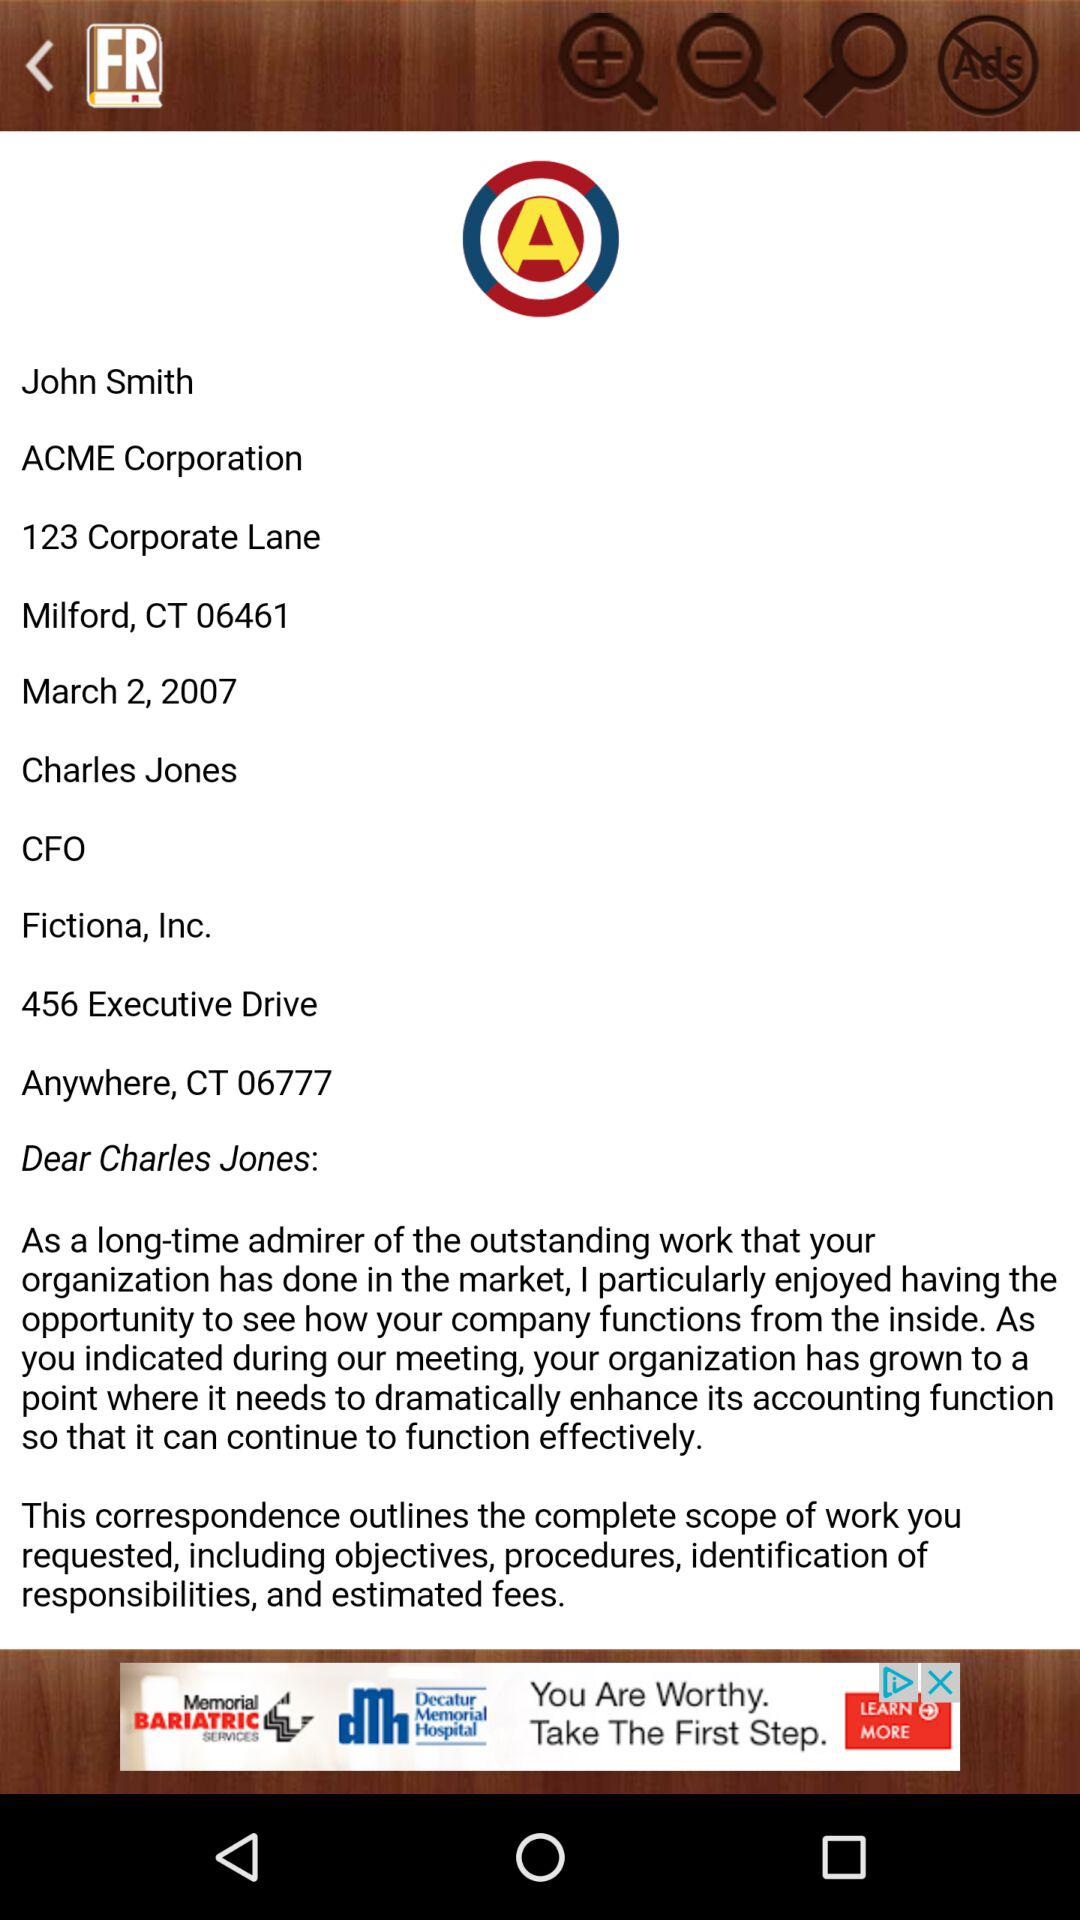What is the name of the user? The name of the user is John Smith. 